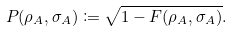<formula> <loc_0><loc_0><loc_500><loc_500>P ( \rho _ { A } , \sigma _ { A } ) \coloneqq \sqrt { 1 - F ( \rho _ { A } , \sigma _ { A } ) } .</formula> 